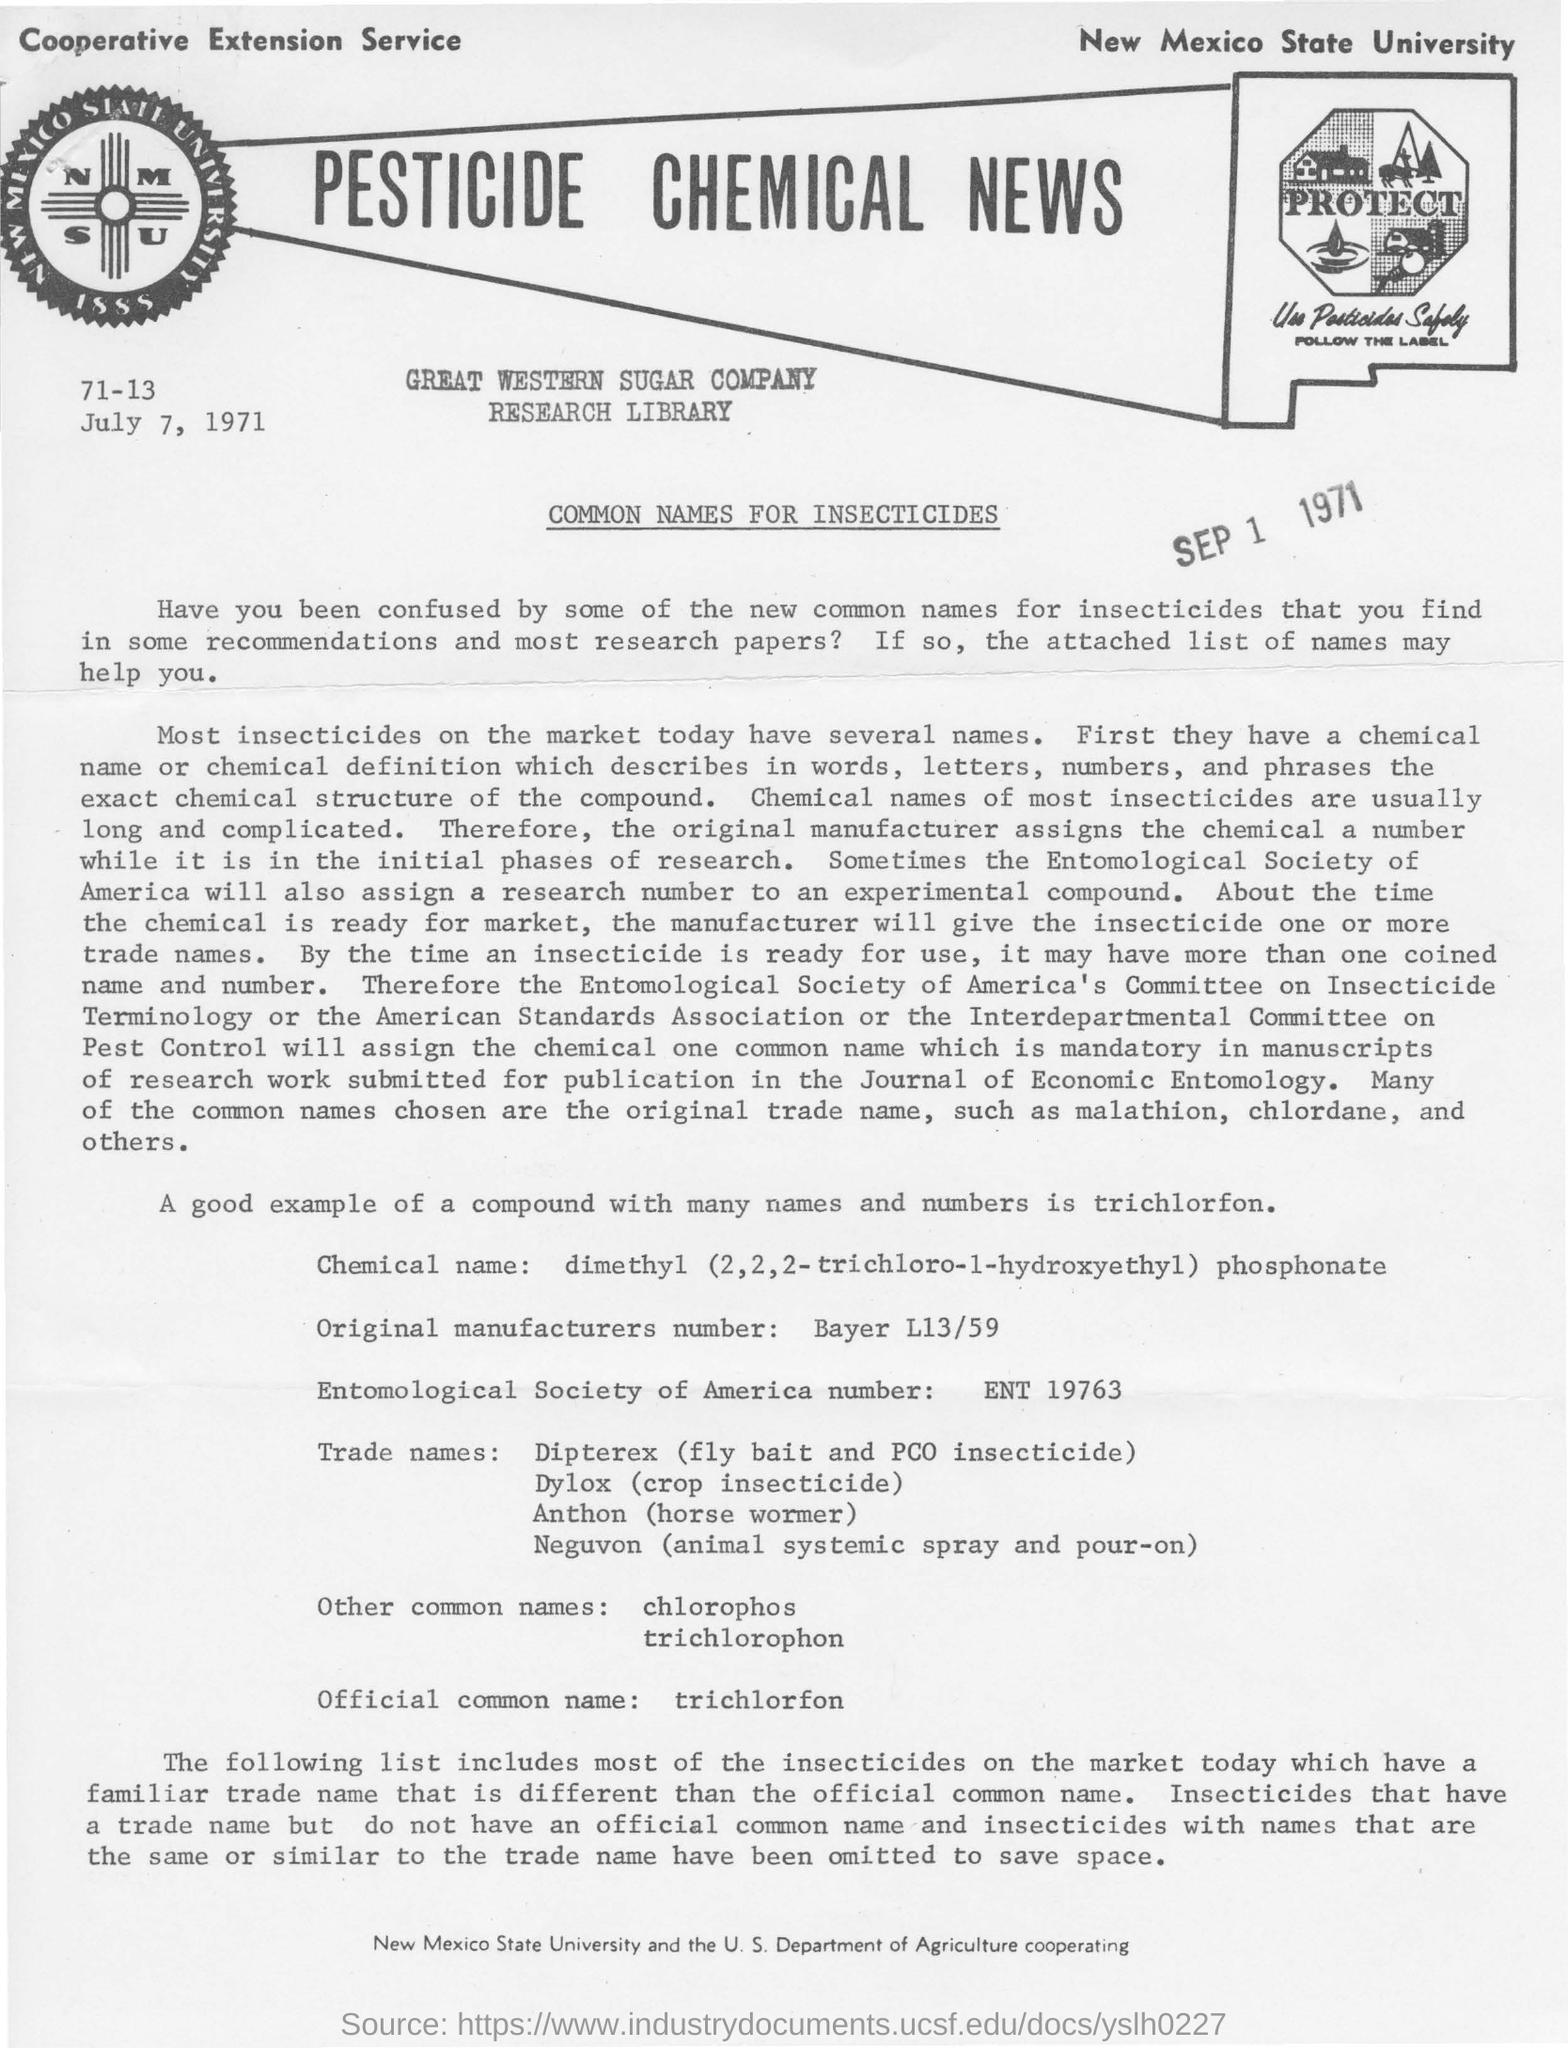List a handful of essential elements in this visual. The university in the top right corner is New Mexico State University. Trichlorfon is a common name for pesticides that is officially recognized. The title of the document is "PESTICIDE CHEMICAL NEWS. 